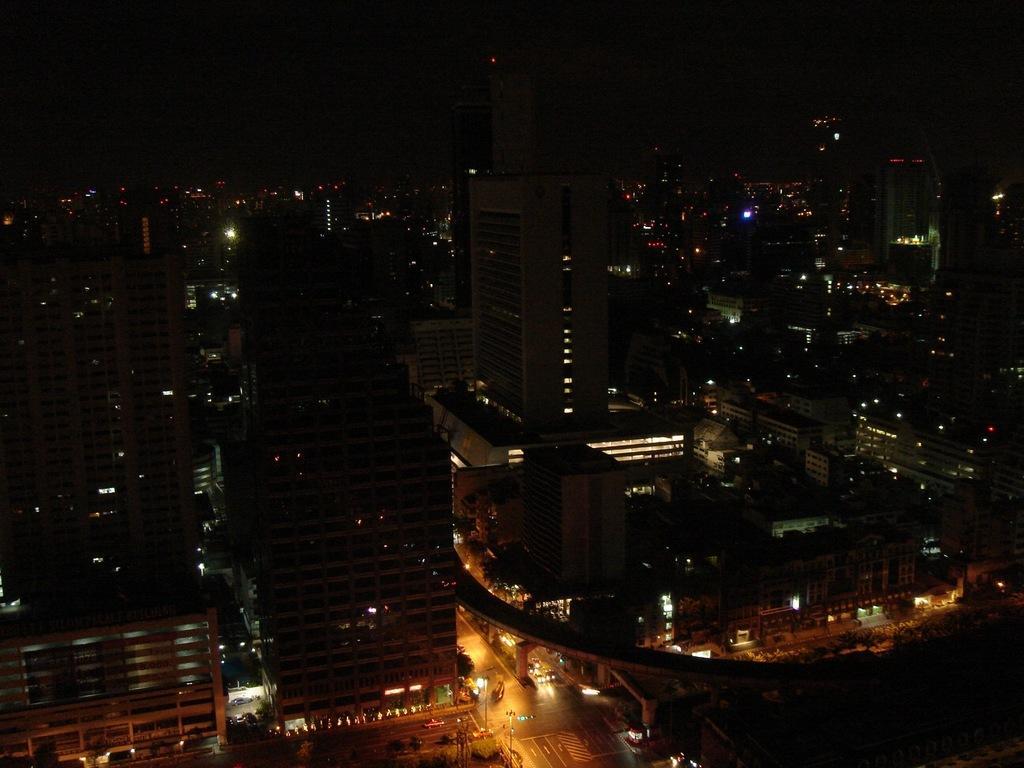Could you give a brief overview of what you see in this image? In the center of the image there are vehicles on the road. There are traffic lights, light poles and buildings. 